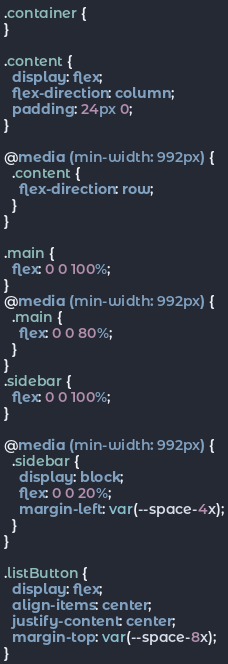Convert code to text. <code><loc_0><loc_0><loc_500><loc_500><_CSS_>.container {
}

.content {
  display: flex;
  flex-direction: column;
  padding: 24px 0;
}

@media (min-width: 992px) {
  .content {
    flex-direction: row;
  }
}

.main {
  flex: 0 0 100%;
}
@media (min-width: 992px) {
  .main {
    flex: 0 0 80%;
  }
}
.sidebar {
  flex: 0 0 100%;
}

@media (min-width: 992px) {
  .sidebar {
    display: block;
    flex: 0 0 20%;
    margin-left: var(--space-4x);
  }
}

.listButton {
  display: flex;
  align-items: center;
  justify-content: center;
  margin-top: var(--space-8x);
}
</code> 